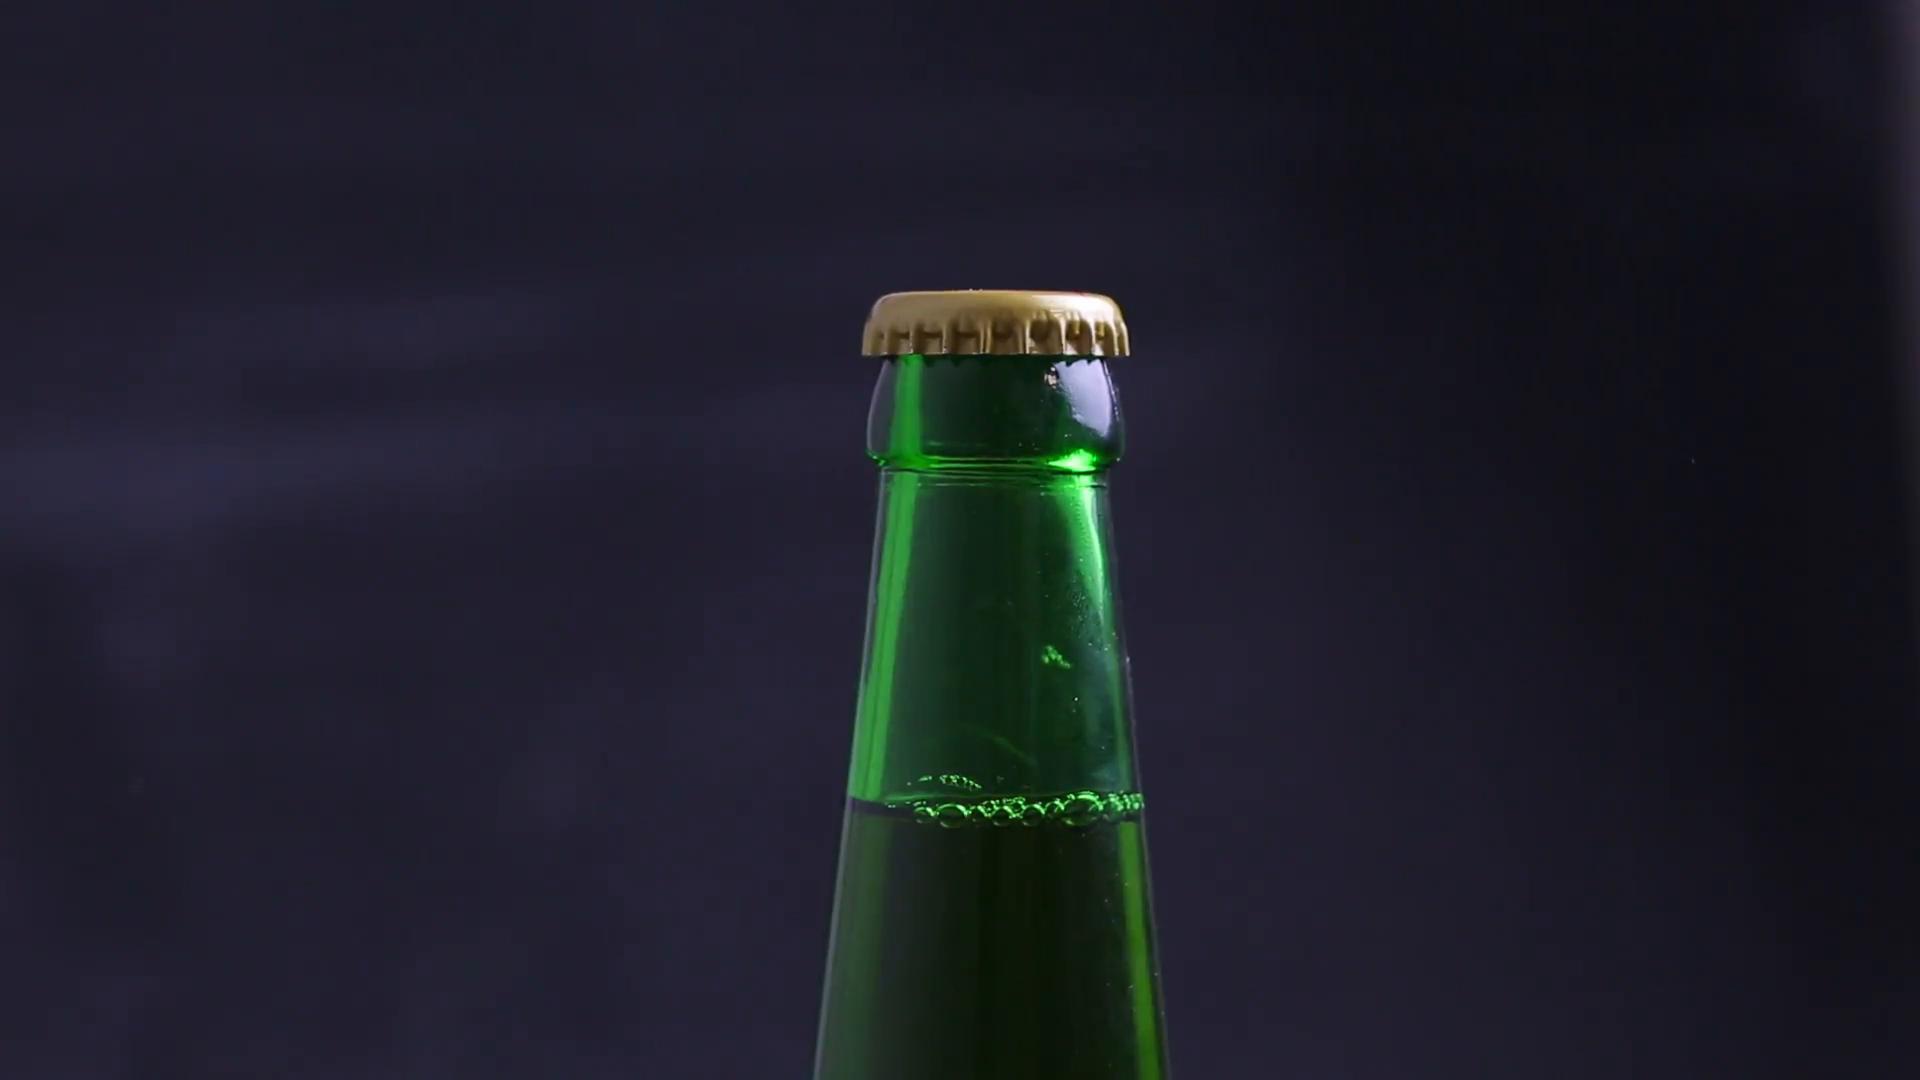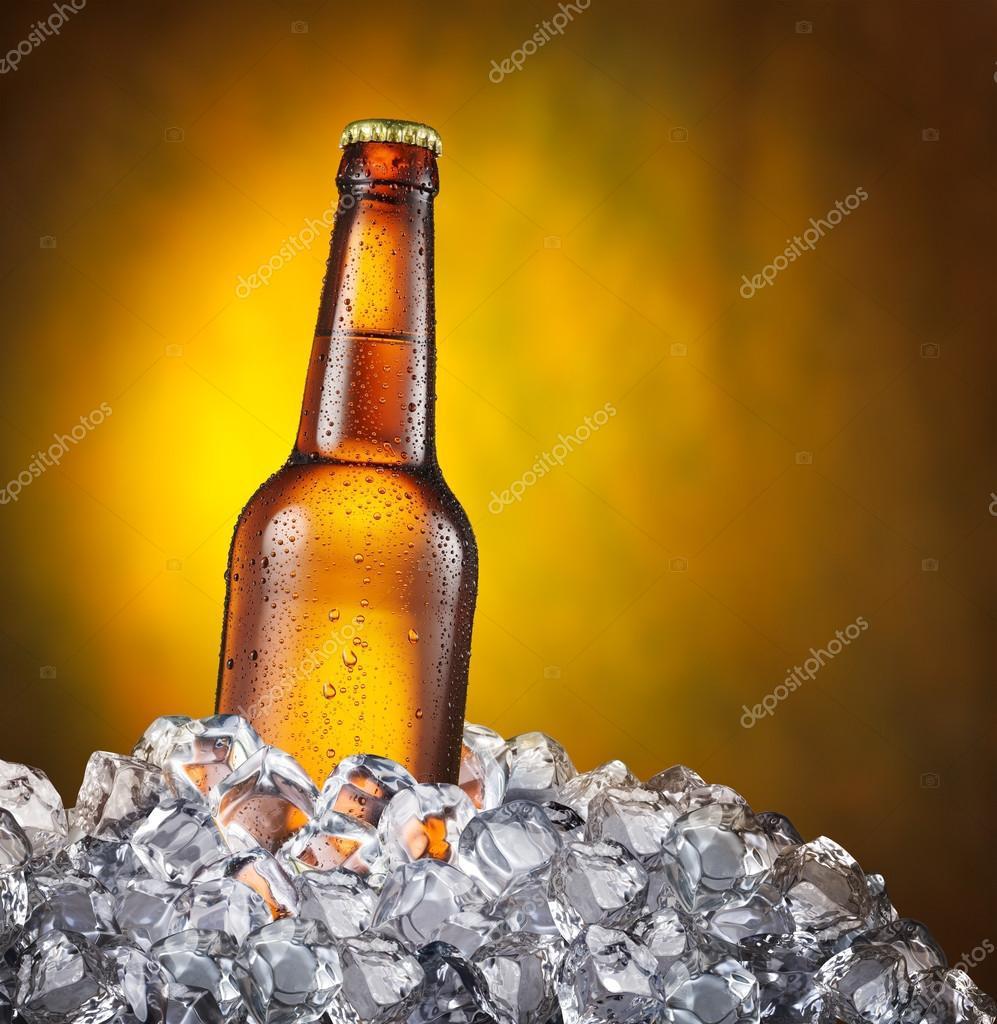The first image is the image on the left, the second image is the image on the right. Given the left and right images, does the statement "An image shows the neck of a green bottle." hold true? Answer yes or no. Yes. 